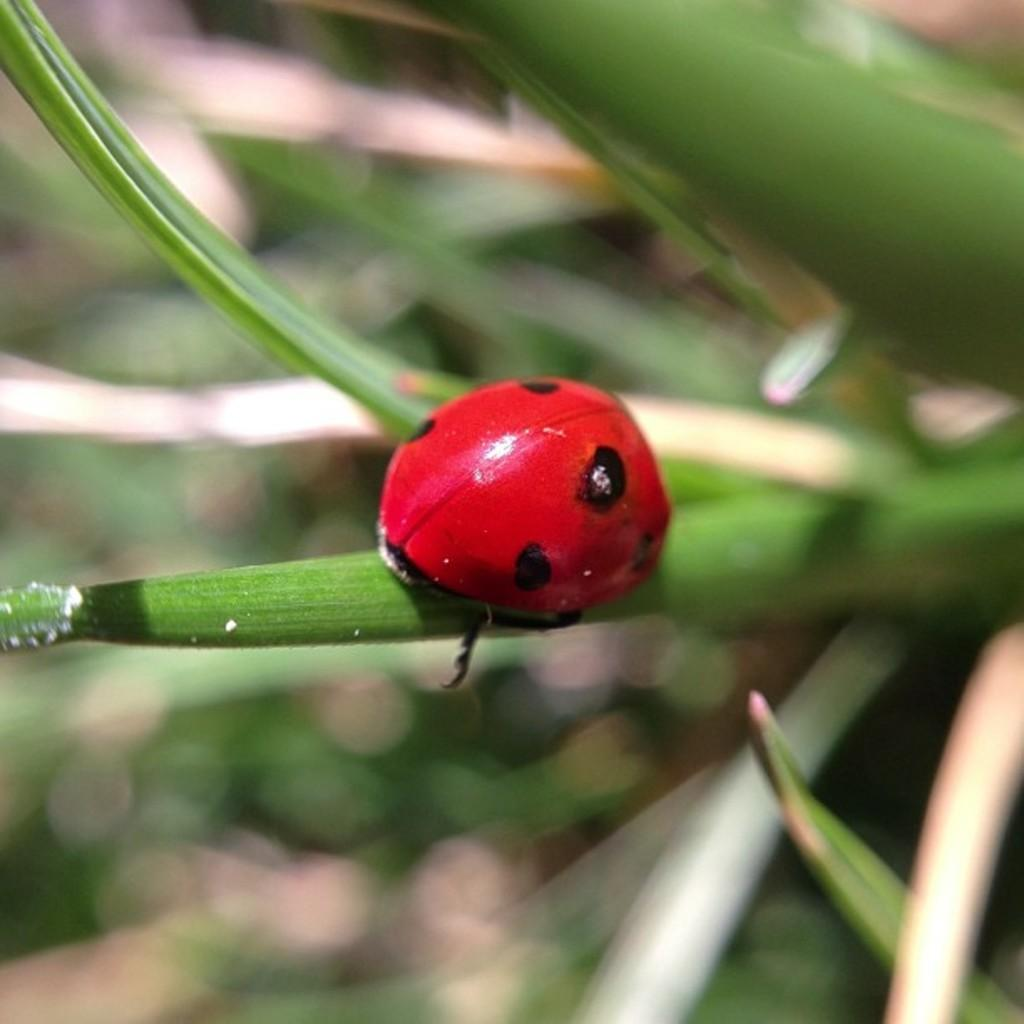What is the main subject of the image? The main subject of the image is an insect on a leaf. Can you describe the background of the image? The background of the image is blurry. What type of grape is being destroyed by the insect in the image? There is no grape present in the image, and the insect is not causing any destruction. 